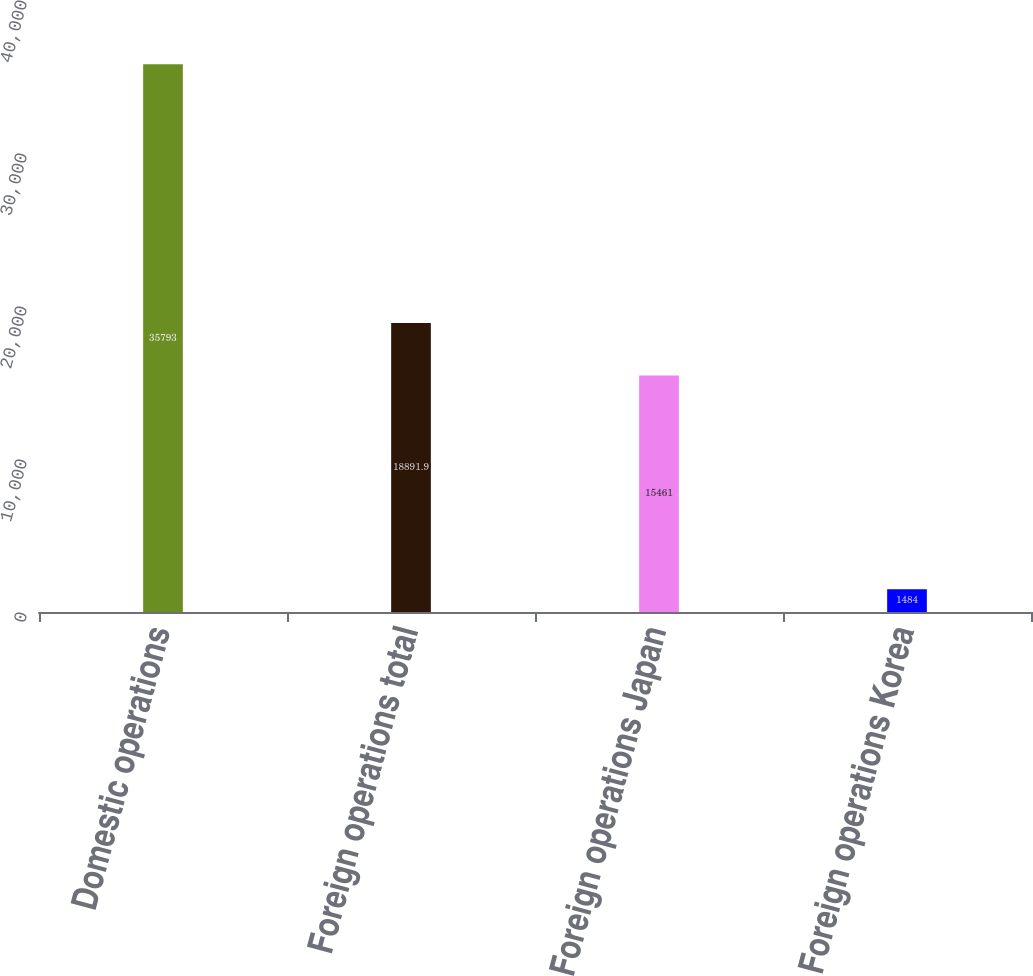<chart> <loc_0><loc_0><loc_500><loc_500><bar_chart><fcel>Domestic operations<fcel>Foreign operations total<fcel>Foreign operations Japan<fcel>Foreign operations Korea<nl><fcel>35793<fcel>18891.9<fcel>15461<fcel>1484<nl></chart> 